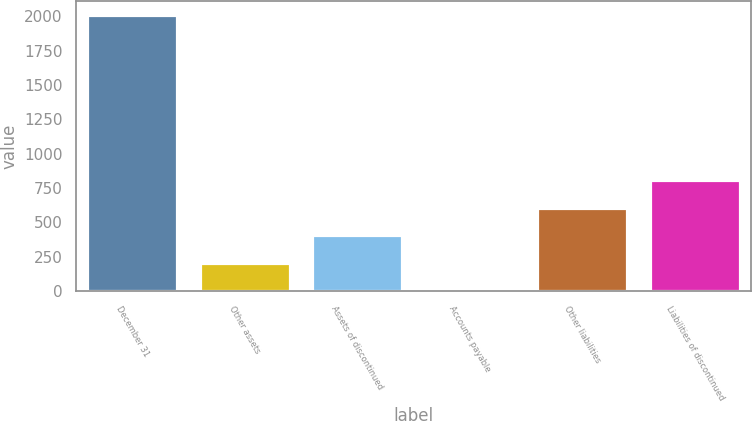<chart> <loc_0><loc_0><loc_500><loc_500><bar_chart><fcel>December 31<fcel>Other assets<fcel>Assets of discontinued<fcel>Accounts payable<fcel>Other liabilities<fcel>Liabilities of discontinued<nl><fcel>2008<fcel>203.5<fcel>404<fcel>3<fcel>604.5<fcel>805<nl></chart> 